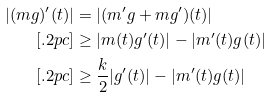Convert formula to latex. <formula><loc_0><loc_0><loc_500><loc_500>| ( m g ) ^ { \prime } ( t ) | & = | ( m ^ { \prime } g + m g ^ { \prime } ) ( t ) | \\ [ . 2 p c ] & \geq | m ( t ) g ^ { \prime } ( t ) | - | m ^ { \prime } ( t ) g ( t ) | \\ [ . 2 p c ] & \geq \frac { k } { 2 } | g ^ { \prime } ( t ) | - | m ^ { \prime } ( t ) g ( t ) |</formula> 